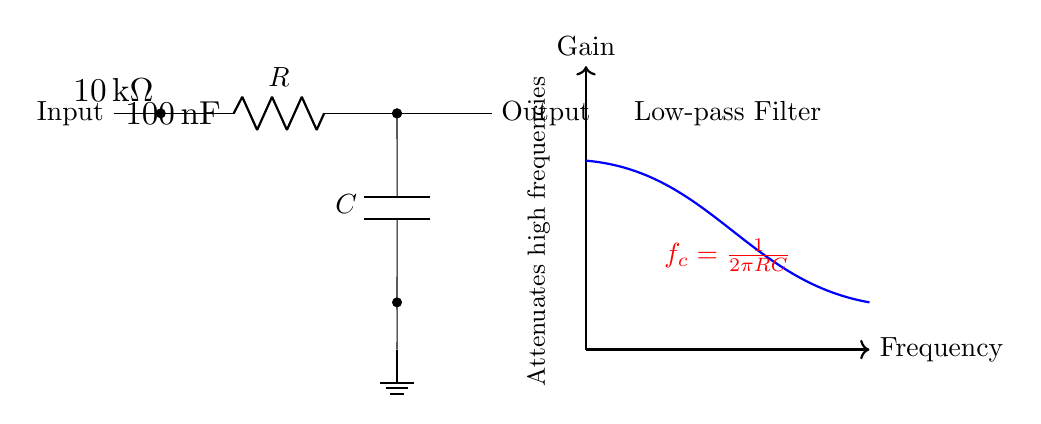What is the value of the resistor in this circuit? The resistor value is indicated in the circuit diagram, marked as R and labeled with a value of 10 kilo-ohms.
Answer: 10 kilo-ohms What type of filter does this circuit represent? The circuit is labeled as a low-pass filter, which allows low frequencies to pass while attenuating high frequencies, as also indicated in the description.
Answer: Low-pass filter What is the capacitance value used in the circuit? The capacitor is marked as C, with a value of 100 nanoFarads written next to it in the diagram.
Answer: 100 nanoFarads What does the red formula represent in this circuit? The red formula indicates the cutoff frequency (f_c) for the low-pass filter, calculated using the resistor and capacitor values, where f_c = 1/(2πRC). This relates to how the circuit's frequency response changes.
Answer: Cutoff frequency At what type of signal is this filter primarily used? This circuit is specifically designed for audio reproduction, as stated in the context of vintage recordings.
Answer: Audio reproduction What does the thick blue line in the diagram illustrate? The thick blue line represents the frequency response curve of the circuit, showing how gain varies with frequency, which visually demonstrates the attenuation of high frequencies by the filter.
Answer: Frequency response curve What is attenuated by this low-pass filter? The circuit is designed to attenuate high frequencies, as mentioned in the labels within the diagram that explain its operational behavior.
Answer: High frequencies 